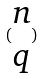<formula> <loc_0><loc_0><loc_500><loc_500>( \begin{matrix} n \\ q \end{matrix} )</formula> 